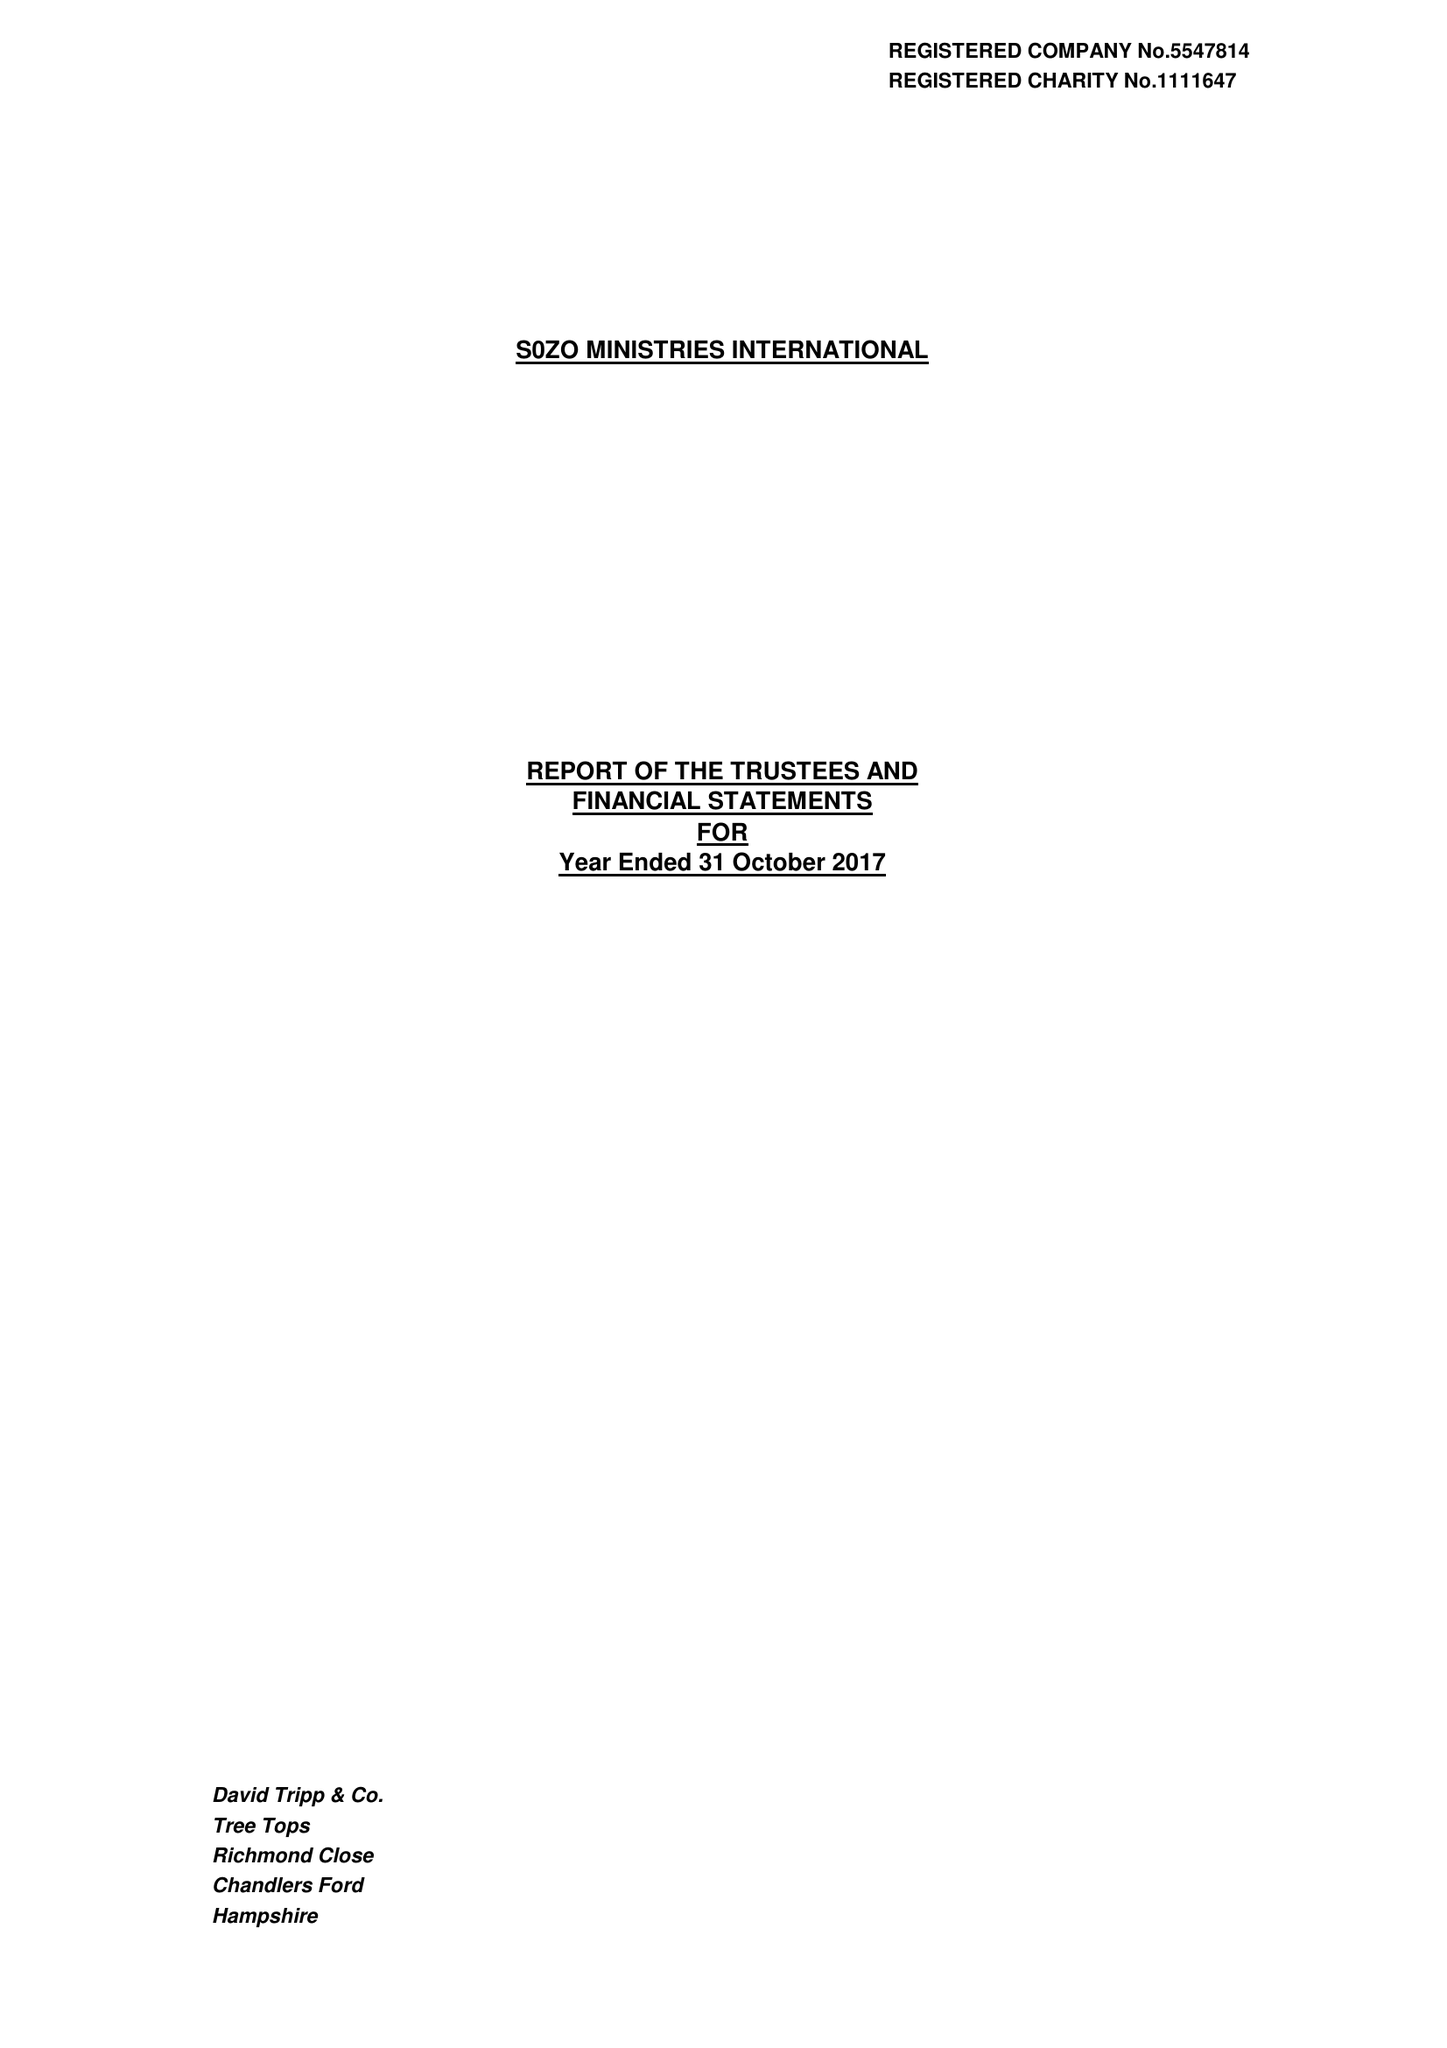What is the value for the address__post_town?
Answer the question using a single word or phrase. ROMSEY 